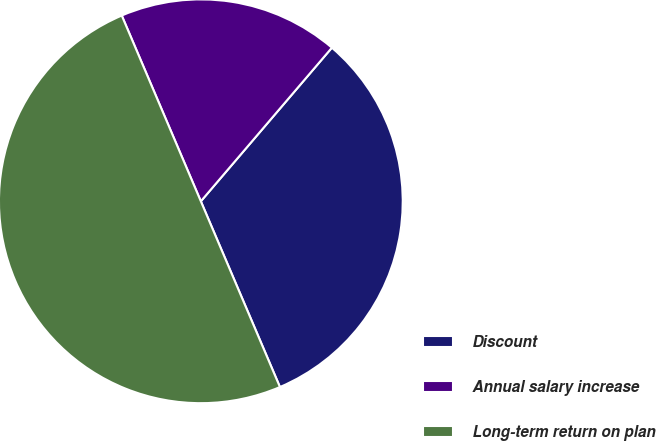Convert chart to OTSL. <chart><loc_0><loc_0><loc_500><loc_500><pie_chart><fcel>Discount<fcel>Annual salary increase<fcel>Long-term return on plan<nl><fcel>32.35%<fcel>17.65%<fcel>50.0%<nl></chart> 